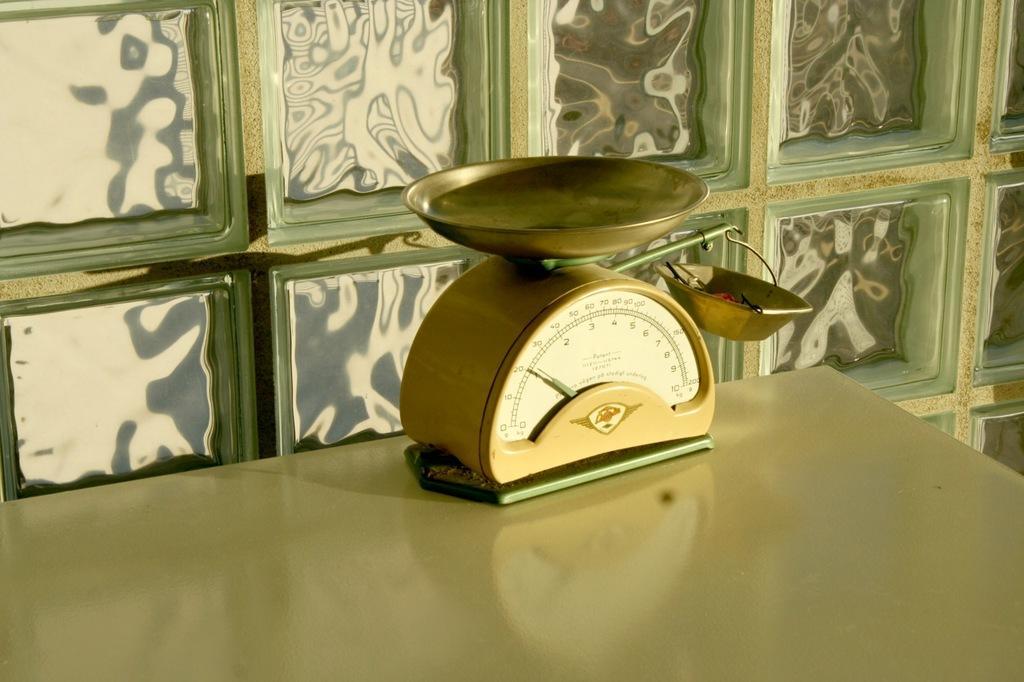How would you summarize this image in a sentence or two? In the picture I can see weighing machine is placed on the table, behind there is a wall. 